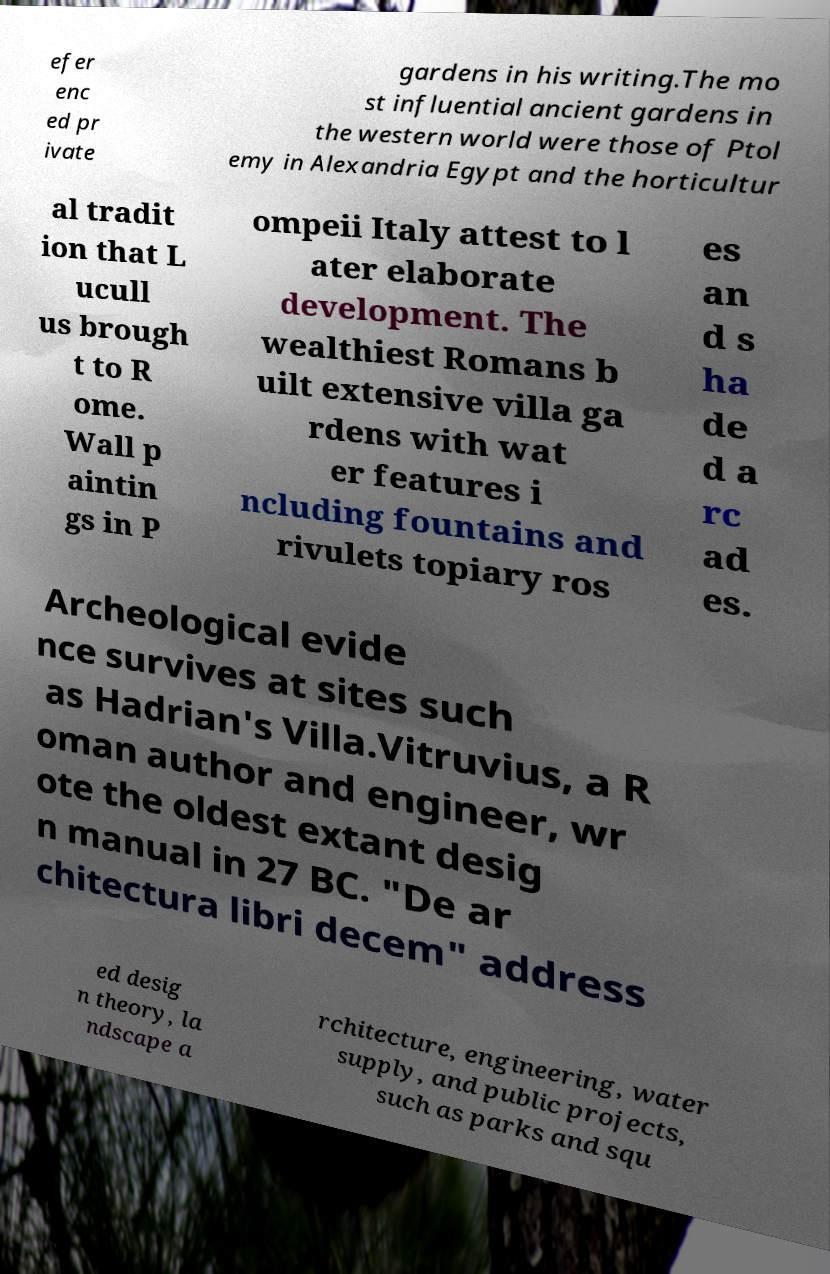There's text embedded in this image that I need extracted. Can you transcribe it verbatim? efer enc ed pr ivate gardens in his writing.The mo st influential ancient gardens in the western world were those of Ptol emy in Alexandria Egypt and the horticultur al tradit ion that L ucull us brough t to R ome. Wall p aintin gs in P ompeii Italy attest to l ater elaborate development. The wealthiest Romans b uilt extensive villa ga rdens with wat er features i ncluding fountains and rivulets topiary ros es an d s ha de d a rc ad es. Archeological evide nce survives at sites such as Hadrian's Villa.Vitruvius, a R oman author and engineer, wr ote the oldest extant desig n manual in 27 BC. "De ar chitectura libri decem" address ed desig n theory, la ndscape a rchitecture, engineering, water supply, and public projects, such as parks and squ 